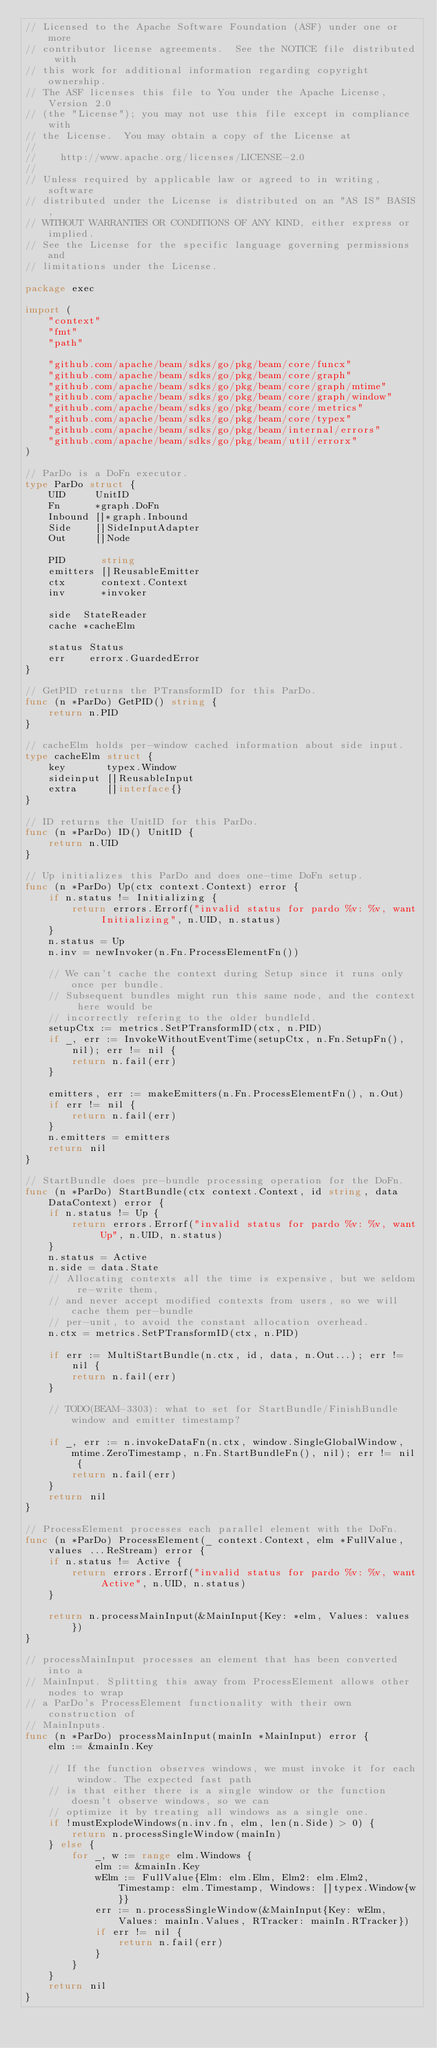Convert code to text. <code><loc_0><loc_0><loc_500><loc_500><_Go_>// Licensed to the Apache Software Foundation (ASF) under one or more
// contributor license agreements.  See the NOTICE file distributed with
// this work for additional information regarding copyright ownership.
// The ASF licenses this file to You under the Apache License, Version 2.0
// (the "License"); you may not use this file except in compliance with
// the License.  You may obtain a copy of the License at
//
//    http://www.apache.org/licenses/LICENSE-2.0
//
// Unless required by applicable law or agreed to in writing, software
// distributed under the License is distributed on an "AS IS" BASIS,
// WITHOUT WARRANTIES OR CONDITIONS OF ANY KIND, either express or implied.
// See the License for the specific language governing permissions and
// limitations under the License.

package exec

import (
	"context"
	"fmt"
	"path"

	"github.com/apache/beam/sdks/go/pkg/beam/core/funcx"
	"github.com/apache/beam/sdks/go/pkg/beam/core/graph"
	"github.com/apache/beam/sdks/go/pkg/beam/core/graph/mtime"
	"github.com/apache/beam/sdks/go/pkg/beam/core/graph/window"
	"github.com/apache/beam/sdks/go/pkg/beam/core/metrics"
	"github.com/apache/beam/sdks/go/pkg/beam/core/typex"
	"github.com/apache/beam/sdks/go/pkg/beam/internal/errors"
	"github.com/apache/beam/sdks/go/pkg/beam/util/errorx"
)

// ParDo is a DoFn executor.
type ParDo struct {
	UID     UnitID
	Fn      *graph.DoFn
	Inbound []*graph.Inbound
	Side    []SideInputAdapter
	Out     []Node

	PID      string
	emitters []ReusableEmitter
	ctx      context.Context
	inv      *invoker

	side  StateReader
	cache *cacheElm

	status Status
	err    errorx.GuardedError
}

// GetPID returns the PTransformID for this ParDo.
func (n *ParDo) GetPID() string {
	return n.PID
}

// cacheElm holds per-window cached information about side input.
type cacheElm struct {
	key       typex.Window
	sideinput []ReusableInput
	extra     []interface{}
}

// ID returns the UnitID for this ParDo.
func (n *ParDo) ID() UnitID {
	return n.UID
}

// Up initializes this ParDo and does one-time DoFn setup.
func (n *ParDo) Up(ctx context.Context) error {
	if n.status != Initializing {
		return errors.Errorf("invalid status for pardo %v: %v, want Initializing", n.UID, n.status)
	}
	n.status = Up
	n.inv = newInvoker(n.Fn.ProcessElementFn())

	// We can't cache the context during Setup since it runs only once per bundle.
	// Subsequent bundles might run this same node, and the context here would be
	// incorrectly refering to the older bundleId.
	setupCtx := metrics.SetPTransformID(ctx, n.PID)
	if _, err := InvokeWithoutEventTime(setupCtx, n.Fn.SetupFn(), nil); err != nil {
		return n.fail(err)
	}

	emitters, err := makeEmitters(n.Fn.ProcessElementFn(), n.Out)
	if err != nil {
		return n.fail(err)
	}
	n.emitters = emitters
	return nil
}

// StartBundle does pre-bundle processing operation for the DoFn.
func (n *ParDo) StartBundle(ctx context.Context, id string, data DataContext) error {
	if n.status != Up {
		return errors.Errorf("invalid status for pardo %v: %v, want Up", n.UID, n.status)
	}
	n.status = Active
	n.side = data.State
	// Allocating contexts all the time is expensive, but we seldom re-write them,
	// and never accept modified contexts from users, so we will cache them per-bundle
	// per-unit, to avoid the constant allocation overhead.
	n.ctx = metrics.SetPTransformID(ctx, n.PID)

	if err := MultiStartBundle(n.ctx, id, data, n.Out...); err != nil {
		return n.fail(err)
	}

	// TODO(BEAM-3303): what to set for StartBundle/FinishBundle window and emitter timestamp?

	if _, err := n.invokeDataFn(n.ctx, window.SingleGlobalWindow, mtime.ZeroTimestamp, n.Fn.StartBundleFn(), nil); err != nil {
		return n.fail(err)
	}
	return nil
}

// ProcessElement processes each parallel element with the DoFn.
func (n *ParDo) ProcessElement(_ context.Context, elm *FullValue, values ...ReStream) error {
	if n.status != Active {
		return errors.Errorf("invalid status for pardo %v: %v, want Active", n.UID, n.status)
	}

	return n.processMainInput(&MainInput{Key: *elm, Values: values})
}

// processMainInput processes an element that has been converted into a
// MainInput. Splitting this away from ProcessElement allows other nodes to wrap
// a ParDo's ProcessElement functionality with their own construction of
// MainInputs.
func (n *ParDo) processMainInput(mainIn *MainInput) error {
	elm := &mainIn.Key

	// If the function observes windows, we must invoke it for each window. The expected fast path
	// is that either there is a single window or the function doesn't observe windows, so we can
	// optimize it by treating all windows as a single one.
	if !mustExplodeWindows(n.inv.fn, elm, len(n.Side) > 0) {
		return n.processSingleWindow(mainIn)
	} else {
		for _, w := range elm.Windows {
			elm := &mainIn.Key
			wElm := FullValue{Elm: elm.Elm, Elm2: elm.Elm2, Timestamp: elm.Timestamp, Windows: []typex.Window{w}}
			err := n.processSingleWindow(&MainInput{Key: wElm, Values: mainIn.Values, RTracker: mainIn.RTracker})
			if err != nil {
				return n.fail(err)
			}
		}
	}
	return nil
}
</code> 